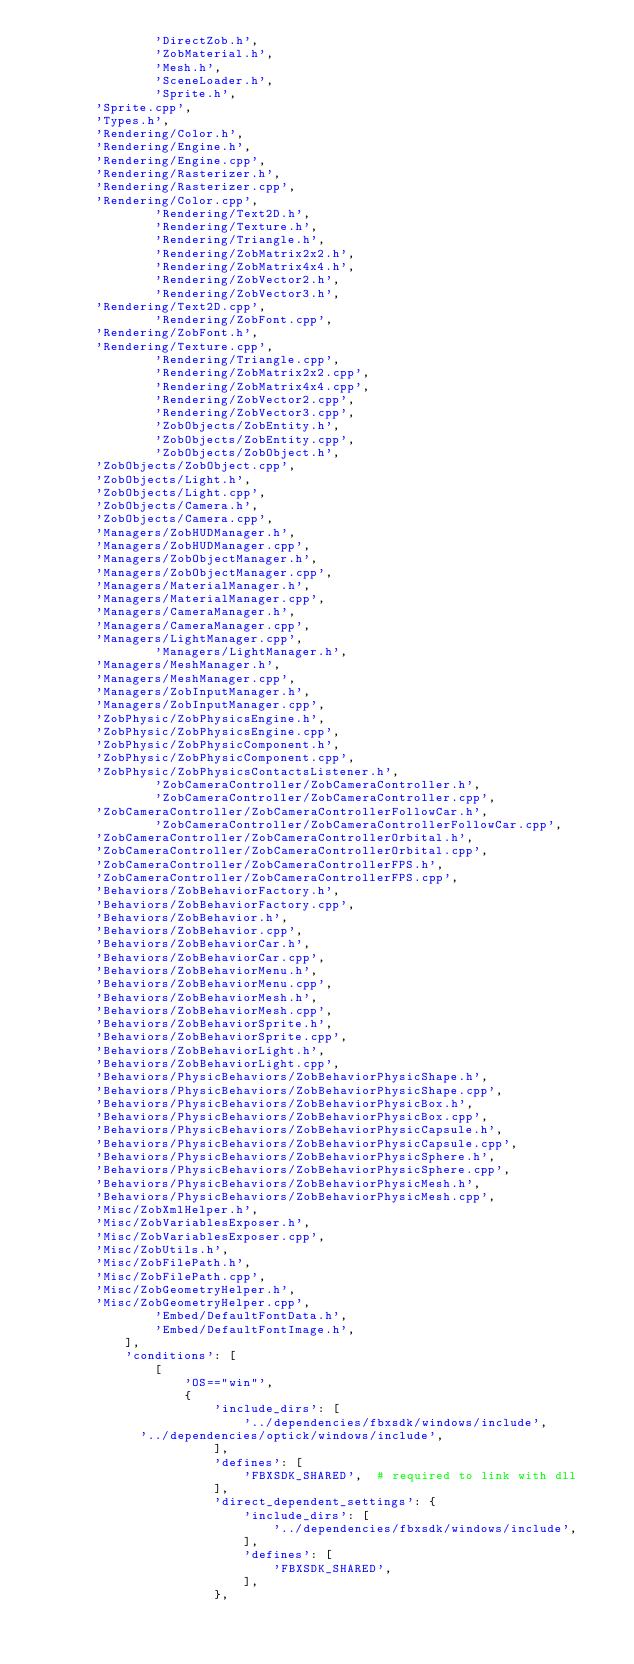<code> <loc_0><loc_0><loc_500><loc_500><_Python_>                'DirectZob.h',
                'ZobMaterial.h',            
                'Mesh.h',         
                'SceneLoader.h',
                'Sprite.h',
				'Sprite.cpp',
				'Types.h',
				'Rendering/Color.h',
				'Rendering/Engine.h',
				'Rendering/Engine.cpp',
				'Rendering/Rasterizer.h',
				'Rendering/Rasterizer.cpp',
				'Rendering/Color.cpp',
                'Rendering/Text2D.h',
                'Rendering/Texture.h',
                'Rendering/Triangle.h',
                'Rendering/ZobMatrix2x2.h',
                'Rendering/ZobMatrix4x4.h',
                'Rendering/ZobVector2.h',
                'Rendering/ZobVector3.h',
				'Rendering/Text2D.cpp',
                'Rendering/ZobFont.cpp',
				'Rendering/ZobFont.h',
				'Rendering/Texture.cpp',
                'Rendering/Triangle.cpp',
                'Rendering/ZobMatrix2x2.cpp',
                'Rendering/ZobMatrix4x4.cpp',
                'Rendering/ZobVector2.cpp',
                'Rendering/ZobVector3.cpp',
                'ZobObjects/ZobEntity.h',
                'ZobObjects/ZobEntity.cpp',
                'ZobObjects/ZobObject.h',
				'ZobObjects/ZobObject.cpp',
				'ZobObjects/Light.h',
				'ZobObjects/Light.cpp',
				'ZobObjects/Camera.h',
				'ZobObjects/Camera.cpp',
				'Managers/ZobHUDManager.h',
				'Managers/ZobHUDManager.cpp',
				'Managers/ZobObjectManager.h',
				'Managers/ZobObjectManager.cpp',
				'Managers/MaterialManager.h',
				'Managers/MaterialManager.cpp',
				'Managers/CameraManager.h',
				'Managers/CameraManager.cpp',
				'Managers/LightManager.cpp',
                'Managers/LightManager.h',
				'Managers/MeshManager.h',
				'Managers/MeshManager.cpp',
				'Managers/ZobInputManager.h',
				'Managers/ZobInputManager.cpp',
				'ZobPhysic/ZobPhysicsEngine.h',
				'ZobPhysic/ZobPhysicsEngine.cpp',
				'ZobPhysic/ZobPhysicComponent.h',
				'ZobPhysic/ZobPhysicComponent.cpp',
				'ZobPhysic/ZobPhysicsContactsListener.h',
                'ZobCameraController/ZobCameraController.h',
                'ZobCameraController/ZobCameraController.cpp',
				'ZobCameraController/ZobCameraControllerFollowCar.h',
                'ZobCameraController/ZobCameraControllerFollowCar.cpp',
				'ZobCameraController/ZobCameraControllerOrbital.h',
				'ZobCameraController/ZobCameraControllerOrbital.cpp',
				'ZobCameraController/ZobCameraControllerFPS.h',
				'ZobCameraController/ZobCameraControllerFPS.cpp',
				'Behaviors/ZobBehaviorFactory.h',
				'Behaviors/ZobBehaviorFactory.cpp',
				'Behaviors/ZobBehavior.h',
				'Behaviors/ZobBehavior.cpp',
				'Behaviors/ZobBehaviorCar.h',
				'Behaviors/ZobBehaviorCar.cpp',
				'Behaviors/ZobBehaviorMenu.h',
				'Behaviors/ZobBehaviorMenu.cpp',
				'Behaviors/ZobBehaviorMesh.h',
				'Behaviors/ZobBehaviorMesh.cpp',
				'Behaviors/ZobBehaviorSprite.h',
				'Behaviors/ZobBehaviorSprite.cpp',	
				'Behaviors/ZobBehaviorLight.h',
				'Behaviors/ZobBehaviorLight.cpp',					
				'Behaviors/PhysicBehaviors/ZobBehaviorPhysicShape.h',
				'Behaviors/PhysicBehaviors/ZobBehaviorPhysicShape.cpp',	
				'Behaviors/PhysicBehaviors/ZobBehaviorPhysicBox.h',
				'Behaviors/PhysicBehaviors/ZobBehaviorPhysicBox.cpp',	
				'Behaviors/PhysicBehaviors/ZobBehaviorPhysicCapsule.h',
				'Behaviors/PhysicBehaviors/ZobBehaviorPhysicCapsule.cpp',	
				'Behaviors/PhysicBehaviors/ZobBehaviorPhysicSphere.h',
				'Behaviors/PhysicBehaviors/ZobBehaviorPhysicSphere.cpp',	
				'Behaviors/PhysicBehaviors/ZobBehaviorPhysicMesh.h',
				'Behaviors/PhysicBehaviors/ZobBehaviorPhysicMesh.cpp',		
				'Misc/ZobXmlHelper.h',		
				'Misc/ZobVariablesExposer.h',
				'Misc/ZobVariablesExposer.cpp',	
				'Misc/ZobUtils.h',	
				'Misc/ZobFilePath.h',
				'Misc/ZobFilePath.cpp',				
				'Misc/ZobGeometryHelper.h',
				'Misc/ZobGeometryHelper.cpp',	
                'Embed/DefaultFontData.h',
                'Embed/DefaultFontImage.h',				
            ],
            'conditions': [
                [
                    'OS=="win"',
                    {
                        'include_dirs': [
                            '../dependencies/fbxsdk/windows/include',
							'../dependencies/optick/windows/include',
                        ],
                        'defines': [
                            'FBXSDK_SHARED',  # required to link with dll
                        ],
                        'direct_dependent_settings': {
                            'include_dirs': [
                                '../dependencies/fbxsdk/windows/include',
                            ],
                            'defines': [
                                'FBXSDK_SHARED',
                            ],
                        },</code> 